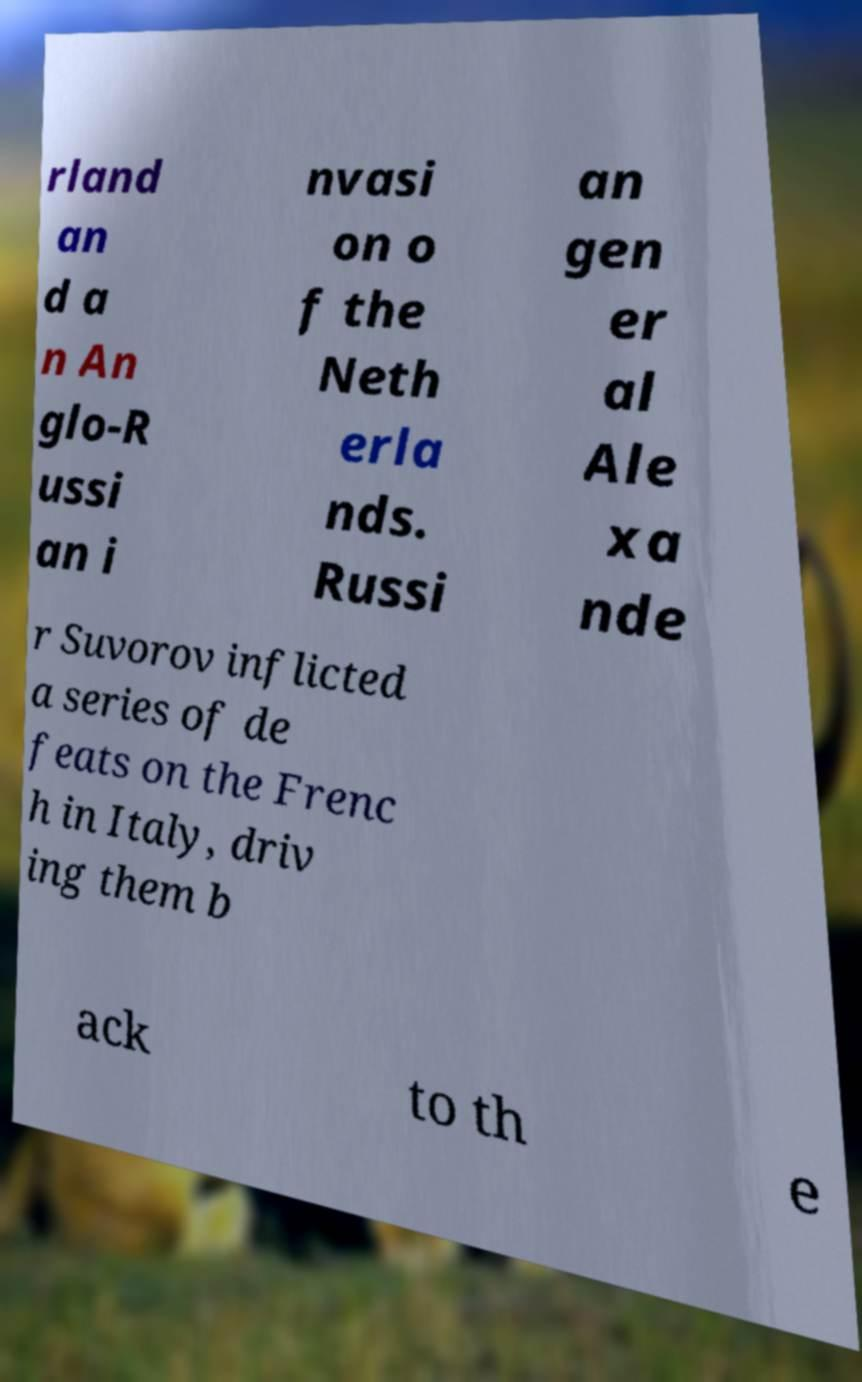Can you read and provide the text displayed in the image?This photo seems to have some interesting text. Can you extract and type it out for me? rland an d a n An glo-R ussi an i nvasi on o f the Neth erla nds. Russi an gen er al Ale xa nde r Suvorov inflicted a series of de feats on the Frenc h in Italy, driv ing them b ack to th e 